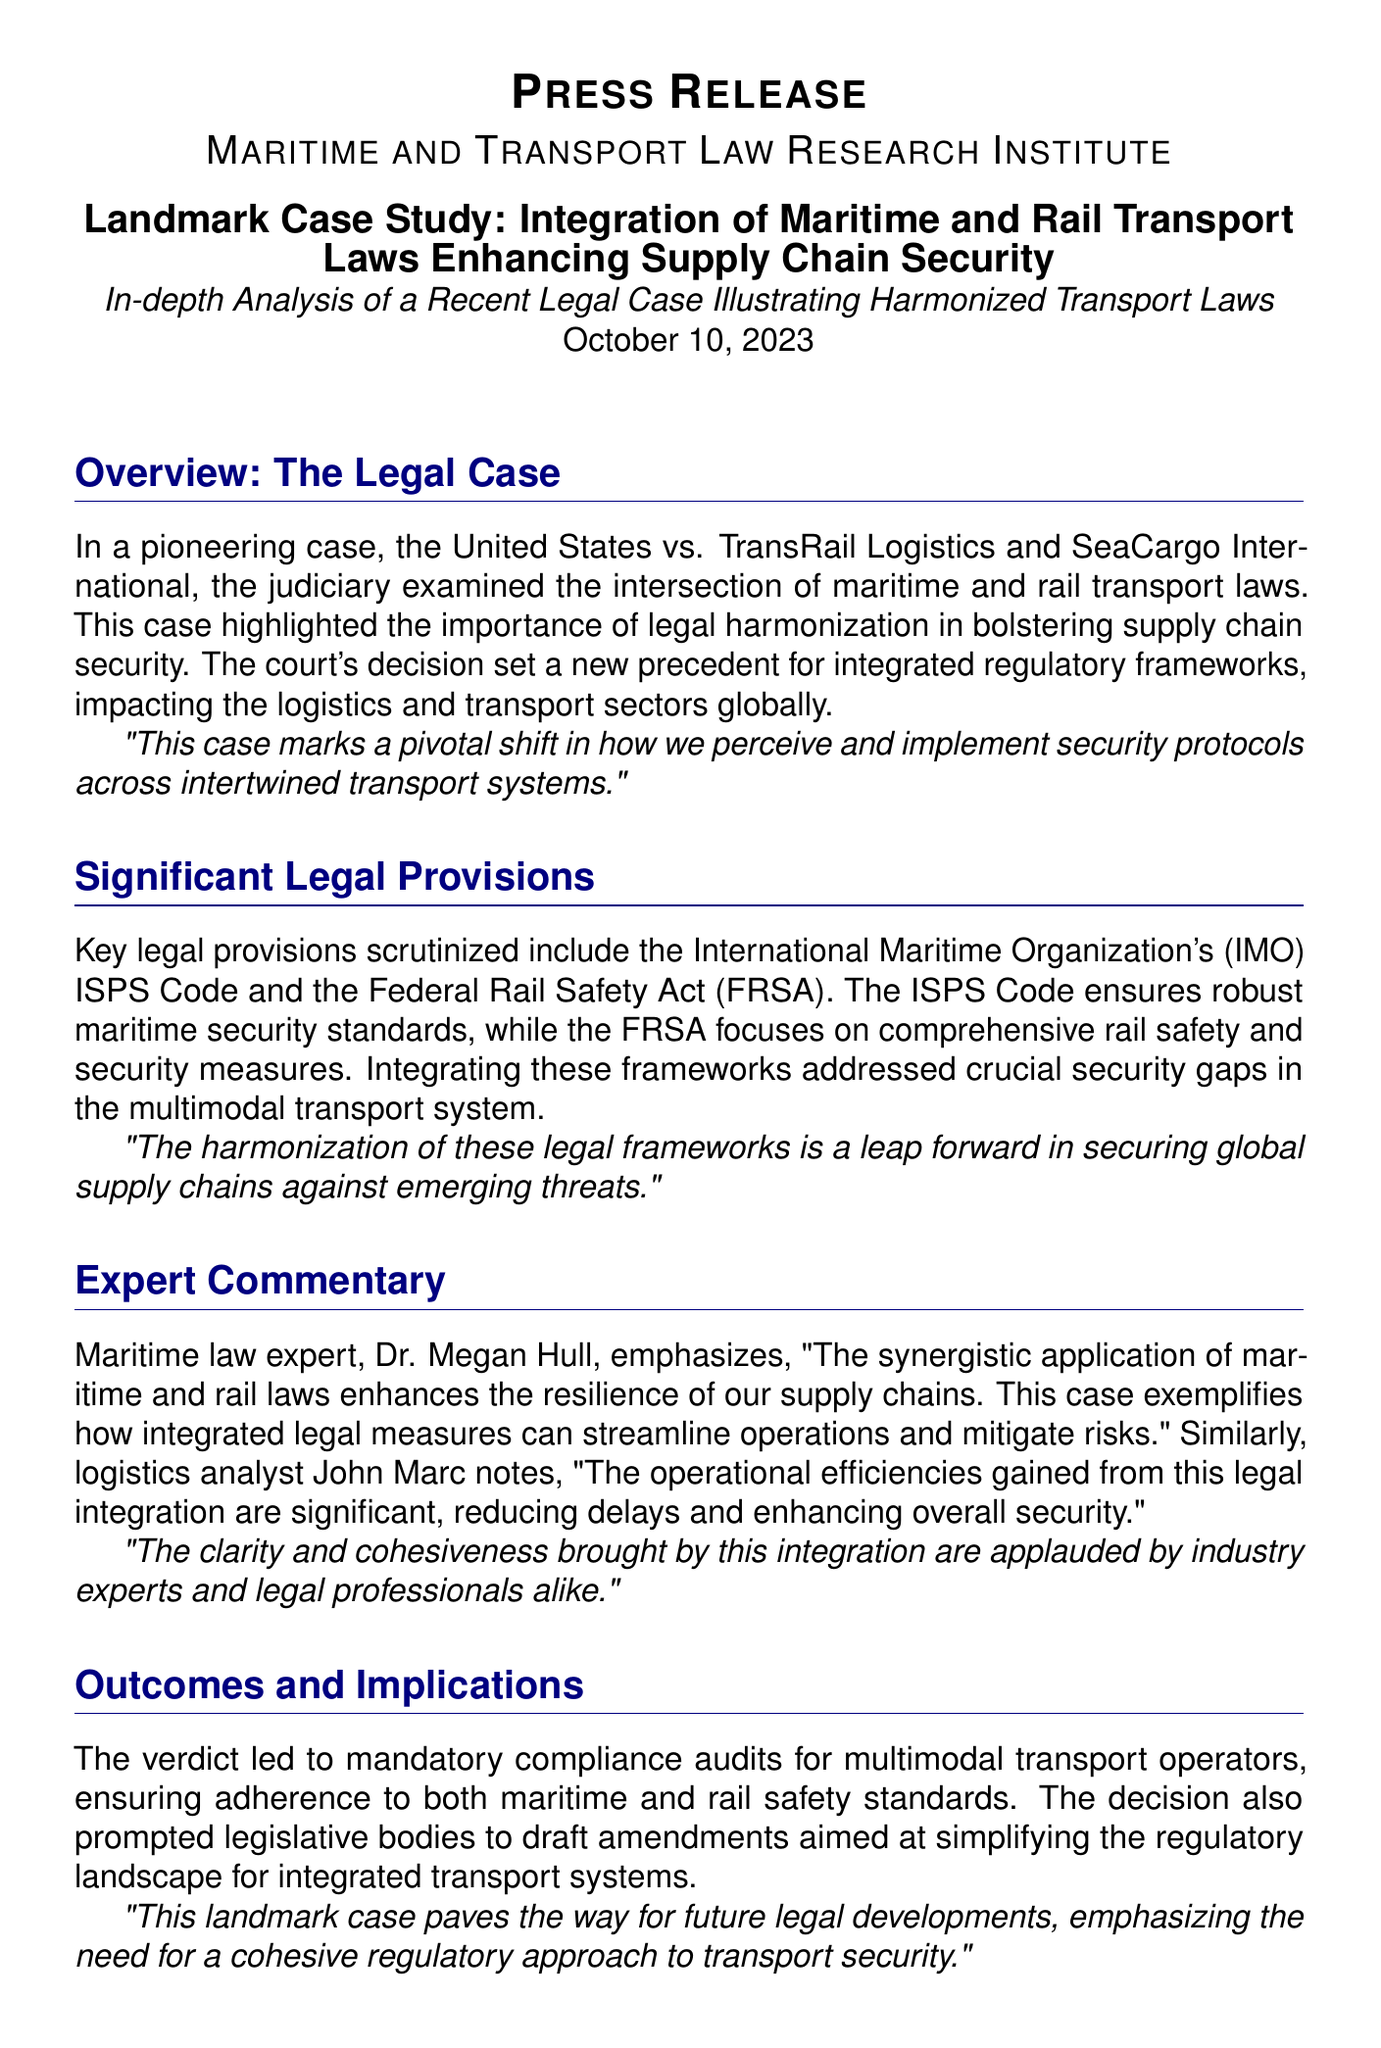what is the title of the case? The title refers to the legal matter explored in the press release, which is about the United States and two companies regarding transport laws.
Answer: United States vs. TransRail Logistics and SeaCargo International what is the date of the press release? This is the date when the press release was officially released, highlighting the relevant legal case.
Answer: October 10, 2023 who emphasized the synergy between maritime and rail laws? This refers to the expert commenting on the importance of combined legal frameworks in enhancing supply chain security.
Answer: Dr. Megan Hull what are the two main legal provisions mentioned? These provisions signify the frameworks focused on maritime security and rail safety that were examined in the case.
Answer: ISPS Code and Federal Rail Safety Act what is one outcome of the case? This refers to a significant result of the court's ruling aimed at improving compliance among transport operators.
Answer: Mandatory compliance audits how did the case affect future legislative actions? This question addresses how the ruling prompted changes in legal frameworks concerning integrated transport systems.
Answer: Prompted legislative bodies to draft amendments what is the primary aim of the ISPS Code? This aims to protect maritime transport by ensuring security standards, a key aspect highlighted in the press release.
Answer: Ensures robust maritime security standards who noted operational efficiencies gained from legal integration? This is another expert who offered insights about the impact of the legal case on logistics operations.
Answer: John Marc 